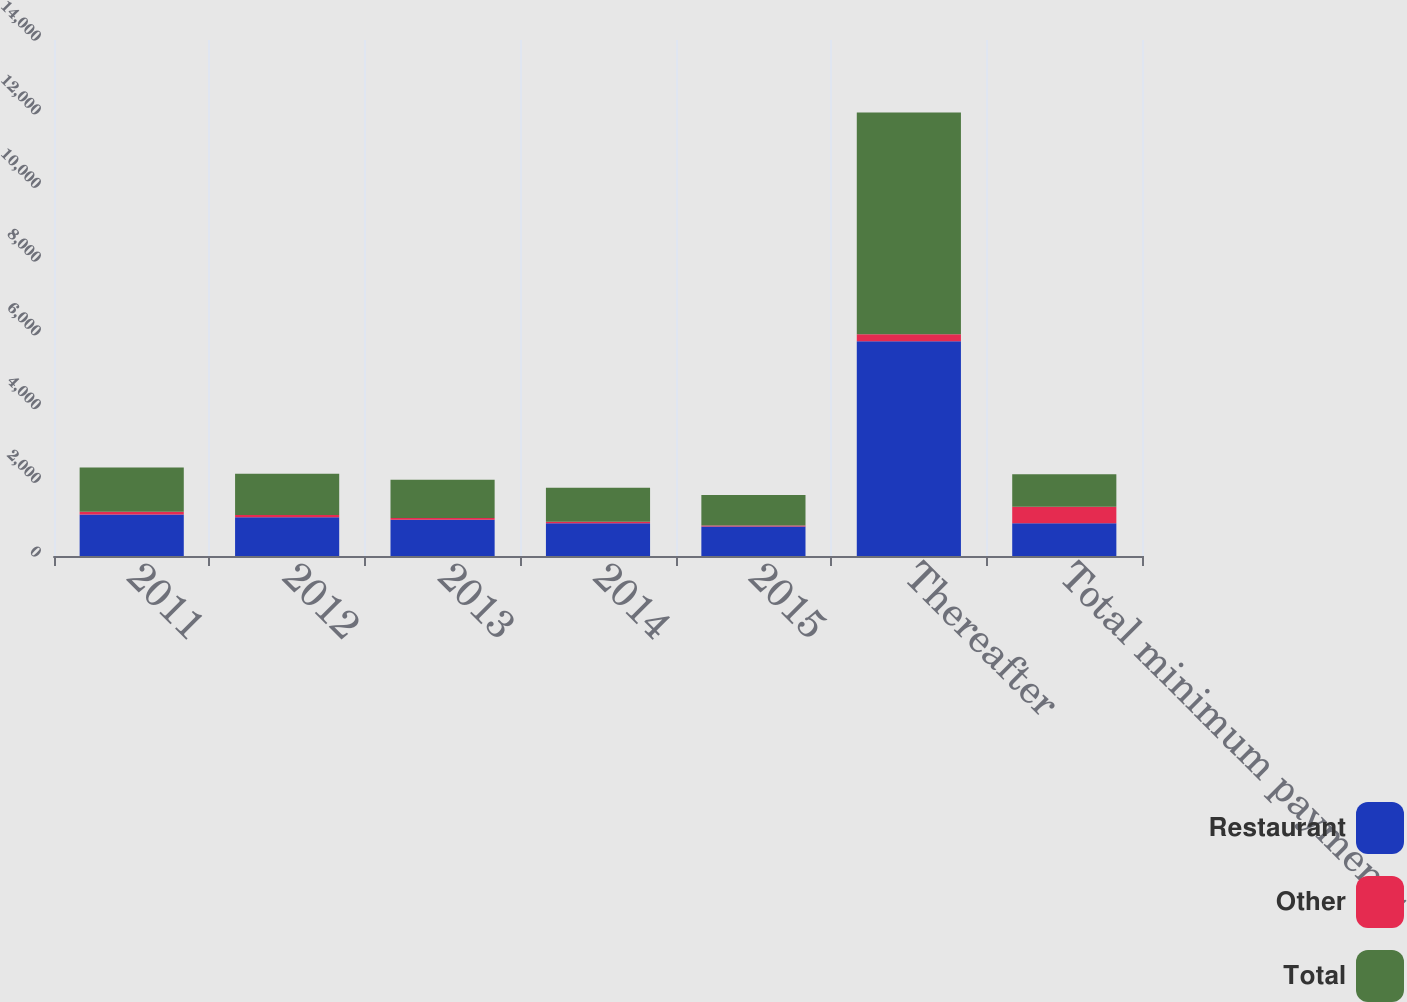Convert chart. <chart><loc_0><loc_0><loc_500><loc_500><stacked_bar_chart><ecel><fcel>2011<fcel>2012<fcel>2013<fcel>2014<fcel>2015<fcel>Thereafter<fcel>Total minimum payments<nl><fcel>Restaurant<fcel>1124.1<fcel>1054.7<fcel>986.7<fcel>885.5<fcel>797.4<fcel>5823.6<fcel>885.5<nl><fcel>Other<fcel>76.4<fcel>60.9<fcel>47.5<fcel>40.4<fcel>29.6<fcel>194.5<fcel>449.3<nl><fcel>Total<fcel>1200.5<fcel>1115.6<fcel>1034.2<fcel>925.9<fcel>827<fcel>6018.1<fcel>885.5<nl></chart> 